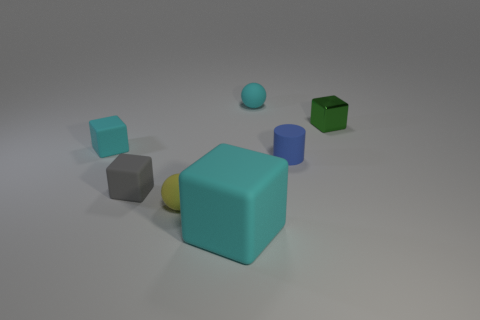What is the size of the matte thing that is both to the left of the cyan ball and right of the small yellow matte sphere?
Your response must be concise. Large. There is a small cyan thing that is the same shape as the big cyan rubber object; what is its material?
Keep it short and to the point. Rubber. Does the cyan rubber cube in front of the gray block have the same size as the small gray object?
Offer a very short reply. No. What is the color of the block that is both right of the small yellow object and behind the gray matte cube?
Offer a very short reply. Green. What number of matte things are on the left side of the cyan rubber block in front of the gray block?
Your answer should be compact. 3. Do the tiny yellow object and the tiny blue object have the same shape?
Provide a short and direct response. No. Are there any other things of the same color as the big matte cube?
Your response must be concise. Yes. There is a blue object; does it have the same shape as the small yellow rubber object on the left side of the tiny blue object?
Offer a very short reply. No. What color is the sphere that is on the left side of the small cyan rubber object that is right of the tiny matte ball in front of the blue cylinder?
Your answer should be compact. Yellow. Are there any other things that are the same material as the large cyan block?
Your answer should be very brief. Yes. 